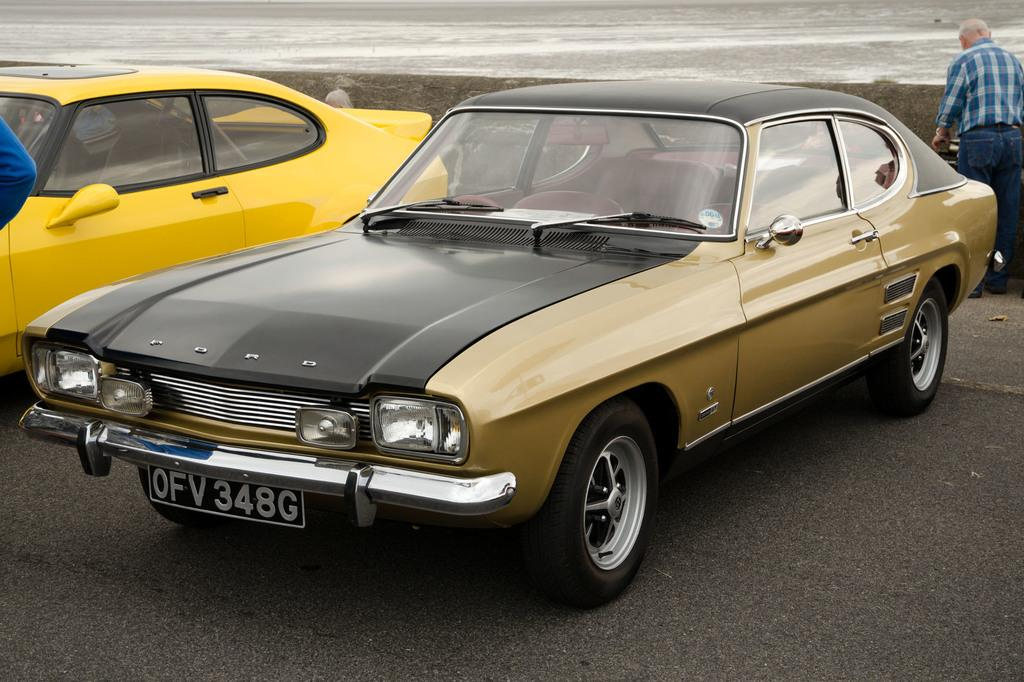What can be seen on the ground in the image? There are two vehicles parked on the ground. What is happening in the background of the image? There are two persons standing in the background. What type of environment is visible in the background? There is water visible in the background. What type of hook can be seen attached to one of the vehicles in the image? There is no hook visible on either of the vehicles in the image. 